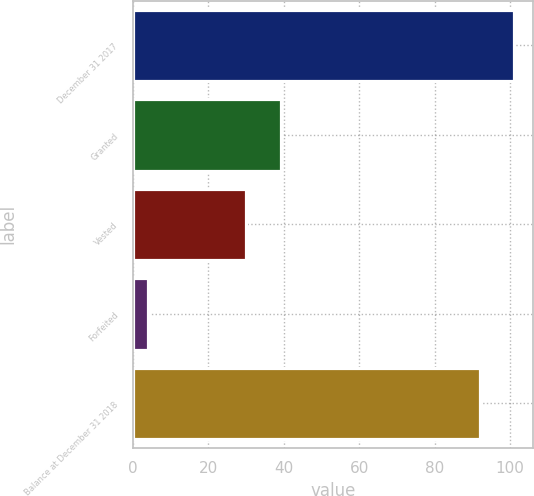Convert chart to OTSL. <chart><loc_0><loc_0><loc_500><loc_500><bar_chart><fcel>December 31 2017<fcel>Granted<fcel>Vested<fcel>Forfeited<fcel>Balance at December 31 2018<nl><fcel>101.1<fcel>39.1<fcel>30<fcel>4<fcel>92<nl></chart> 